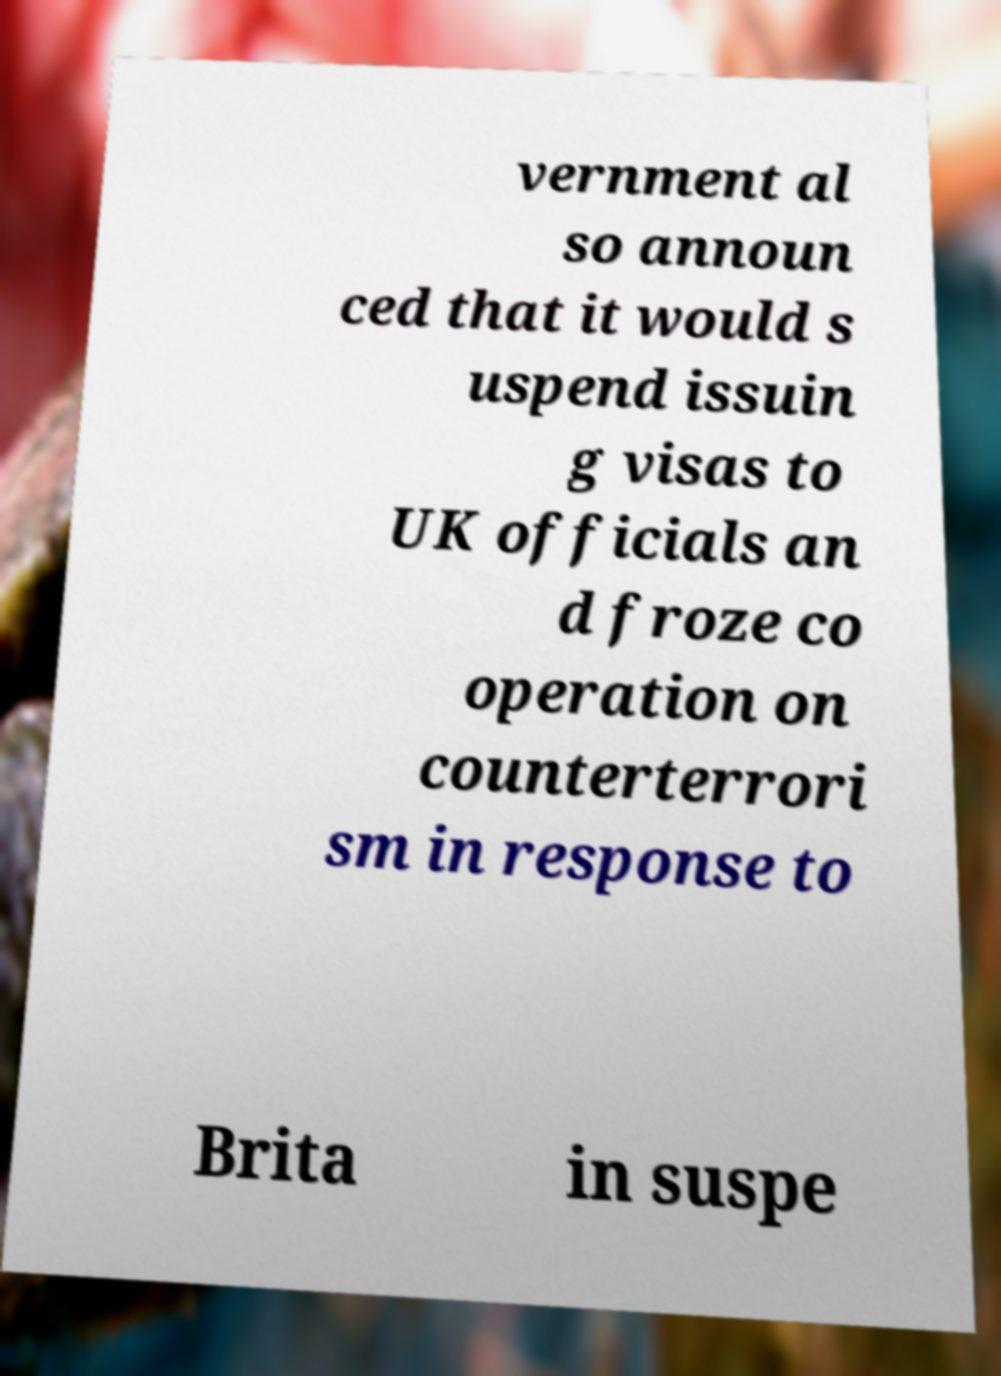Can you accurately transcribe the text from the provided image for me? vernment al so announ ced that it would s uspend issuin g visas to UK officials an d froze co operation on counterterrori sm in response to Brita in suspe 